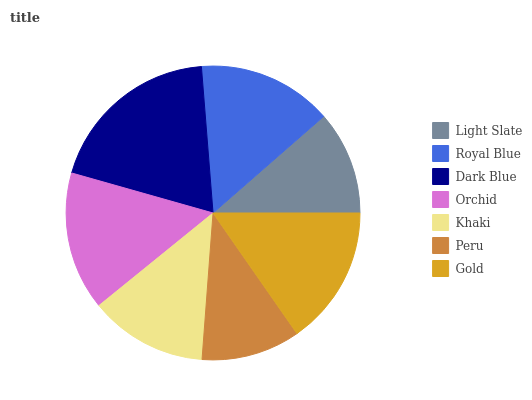Is Peru the minimum?
Answer yes or no. Yes. Is Dark Blue the maximum?
Answer yes or no. Yes. Is Royal Blue the minimum?
Answer yes or no. No. Is Royal Blue the maximum?
Answer yes or no. No. Is Royal Blue greater than Light Slate?
Answer yes or no. Yes. Is Light Slate less than Royal Blue?
Answer yes or no. Yes. Is Light Slate greater than Royal Blue?
Answer yes or no. No. Is Royal Blue less than Light Slate?
Answer yes or no. No. Is Royal Blue the high median?
Answer yes or no. Yes. Is Royal Blue the low median?
Answer yes or no. Yes. Is Khaki the high median?
Answer yes or no. No. Is Peru the low median?
Answer yes or no. No. 